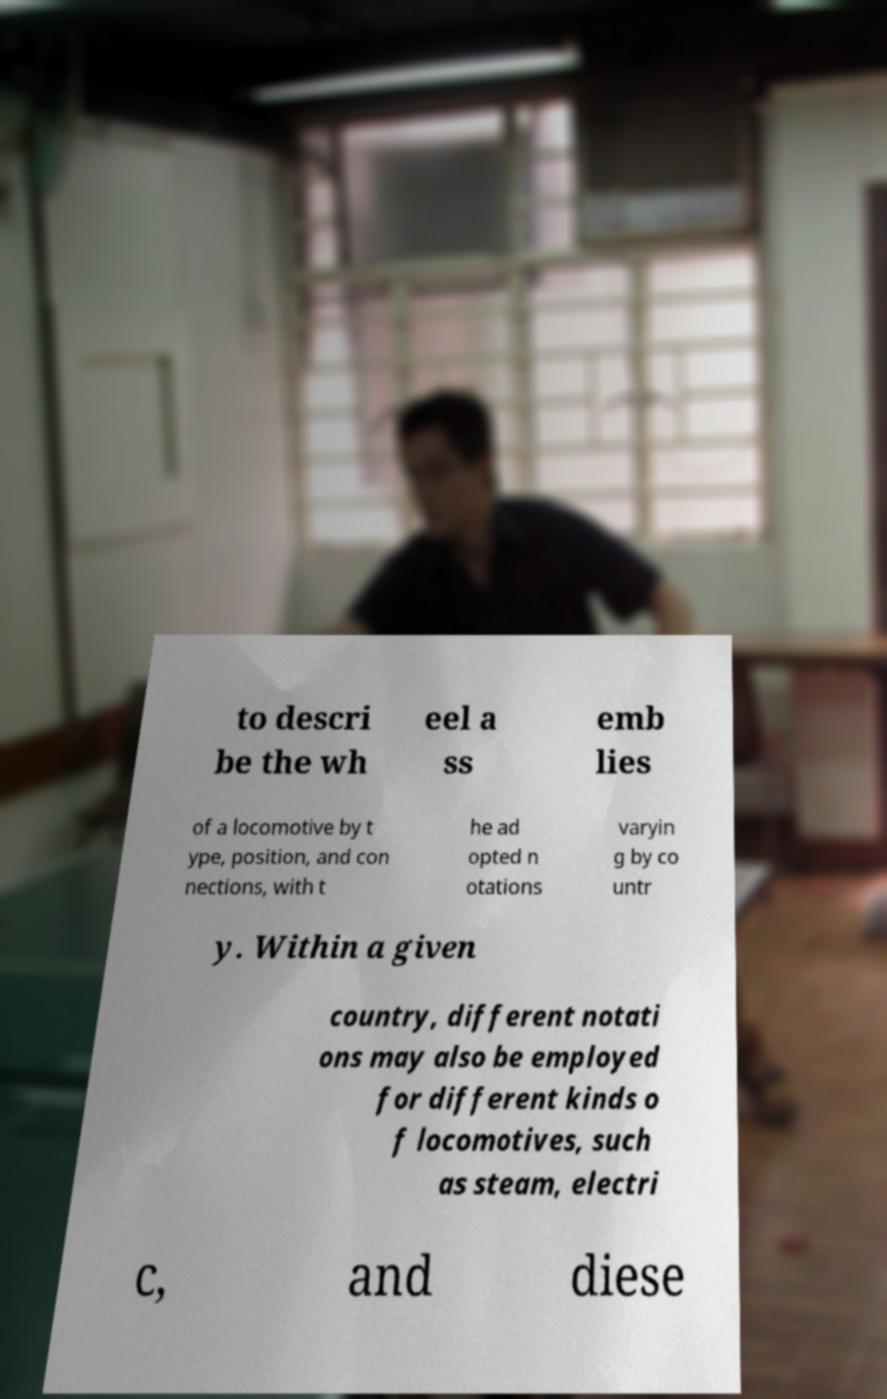For documentation purposes, I need the text within this image transcribed. Could you provide that? to descri be the wh eel a ss emb lies of a locomotive by t ype, position, and con nections, with t he ad opted n otations varyin g by co untr y. Within a given country, different notati ons may also be employed for different kinds o f locomotives, such as steam, electri c, and diese 